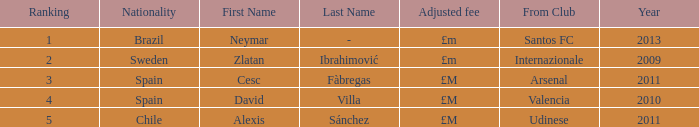Where is the ranked 2 players from? Internazionale. 